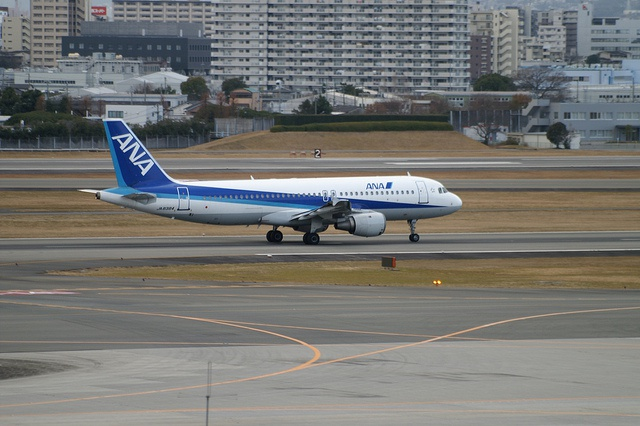Describe the objects in this image and their specific colors. I can see a airplane in darkgray, lightgray, gray, blue, and black tones in this image. 